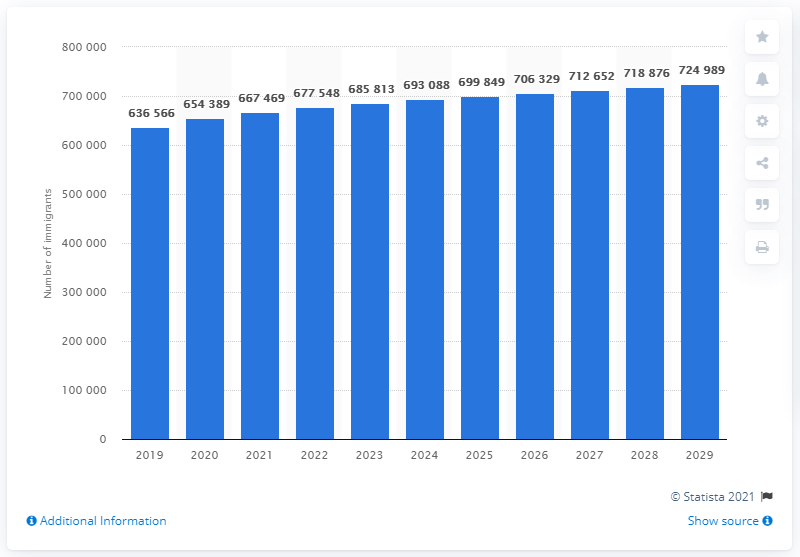Indicate a few pertinent items in this graphic. It is projected that Denmark will experience an increase in immigrants by the year 2029. It is projected that by 2029, a total of 724,989 immigrants will be living in Denmark. 